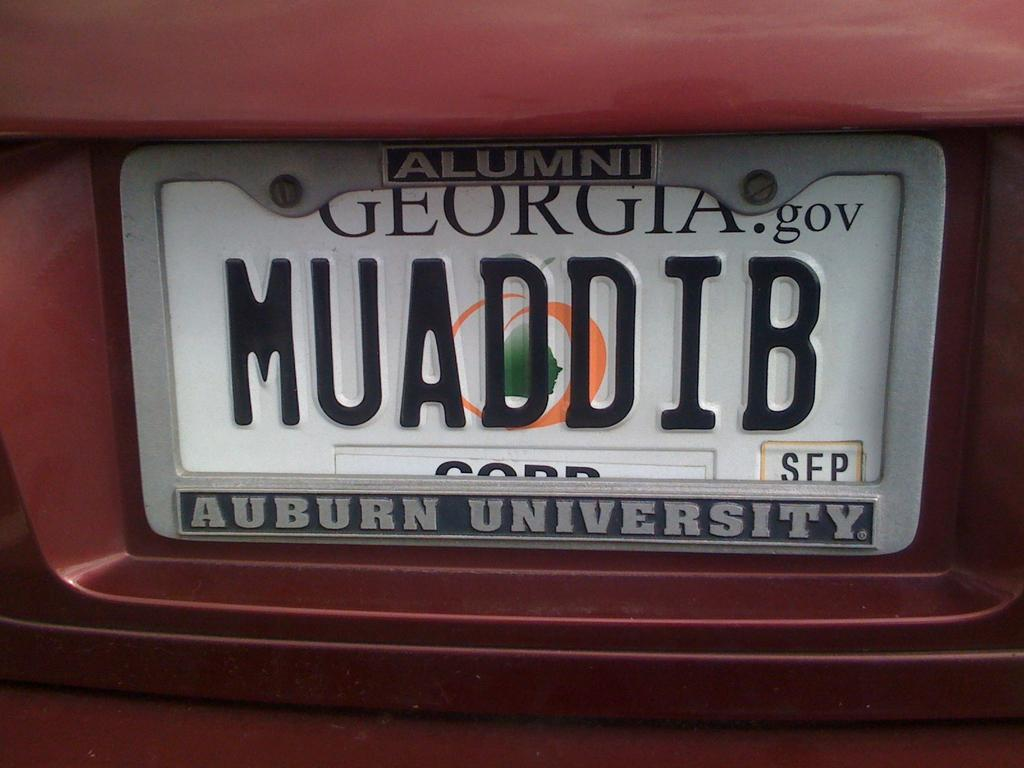<image>
Render a clear and concise summary of the photo. Red car with a license plate from Georgia which says MUADDIB. 